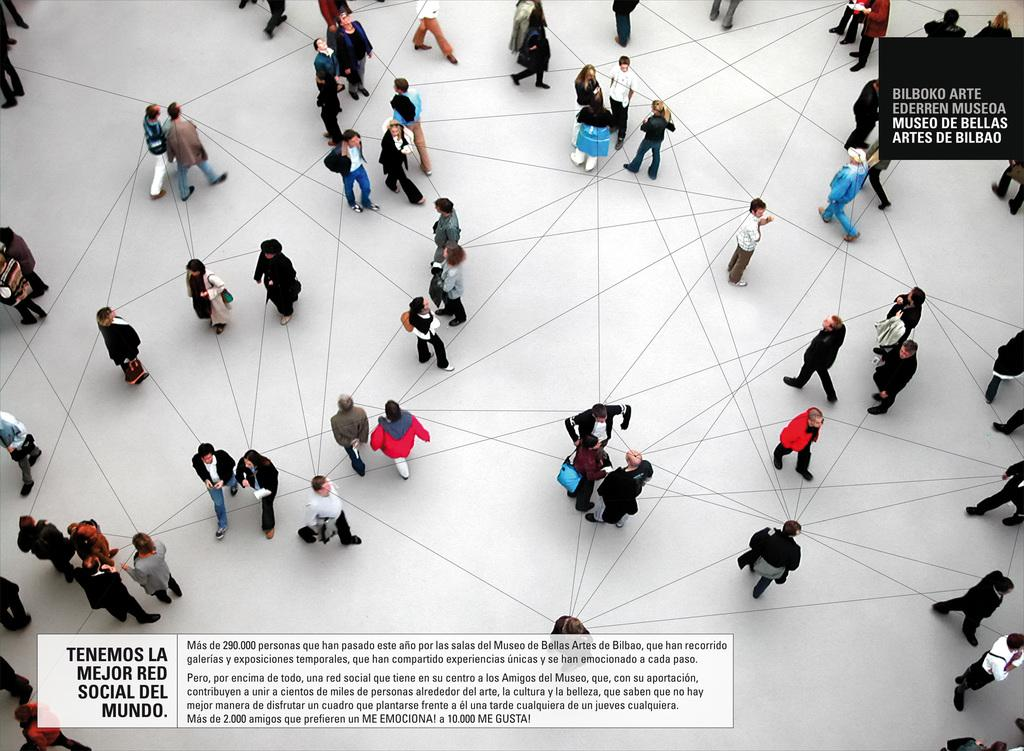What is the main subject of the image? The main subject of the image is a group of people. What are some of the people in the image doing? Some people are standing, and some are walking in the image. What objects can be seen with the people in the image? Bags are visible in the image. Is there any text present in the image? Yes, there is some text in the image. Can you hear a chicken whistling in the image? There is no chicken or whistling present in the image. 